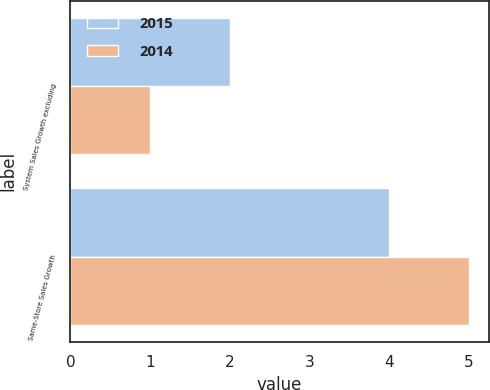Convert chart. <chart><loc_0><loc_0><loc_500><loc_500><stacked_bar_chart><ecel><fcel>System Sales Growth excluding<fcel>Same-Store Sales Growth<nl><fcel>2015<fcel>2<fcel>4<nl><fcel>2014<fcel>1<fcel>5<nl></chart> 